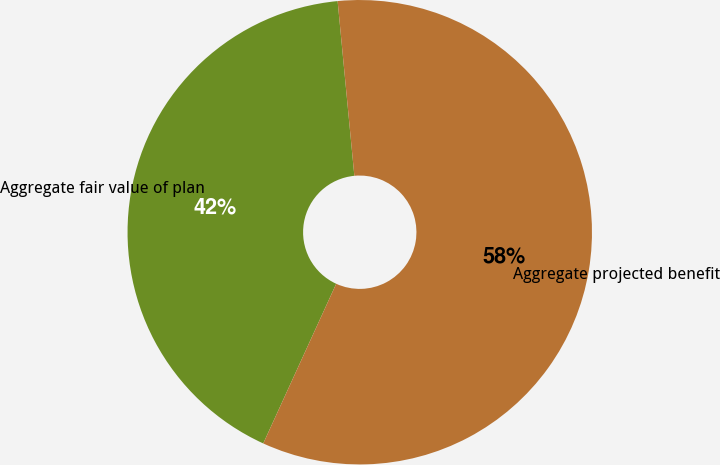Convert chart to OTSL. <chart><loc_0><loc_0><loc_500><loc_500><pie_chart><fcel>Aggregate fair value of plan<fcel>Aggregate projected benefit<nl><fcel>41.66%<fcel>58.34%<nl></chart> 